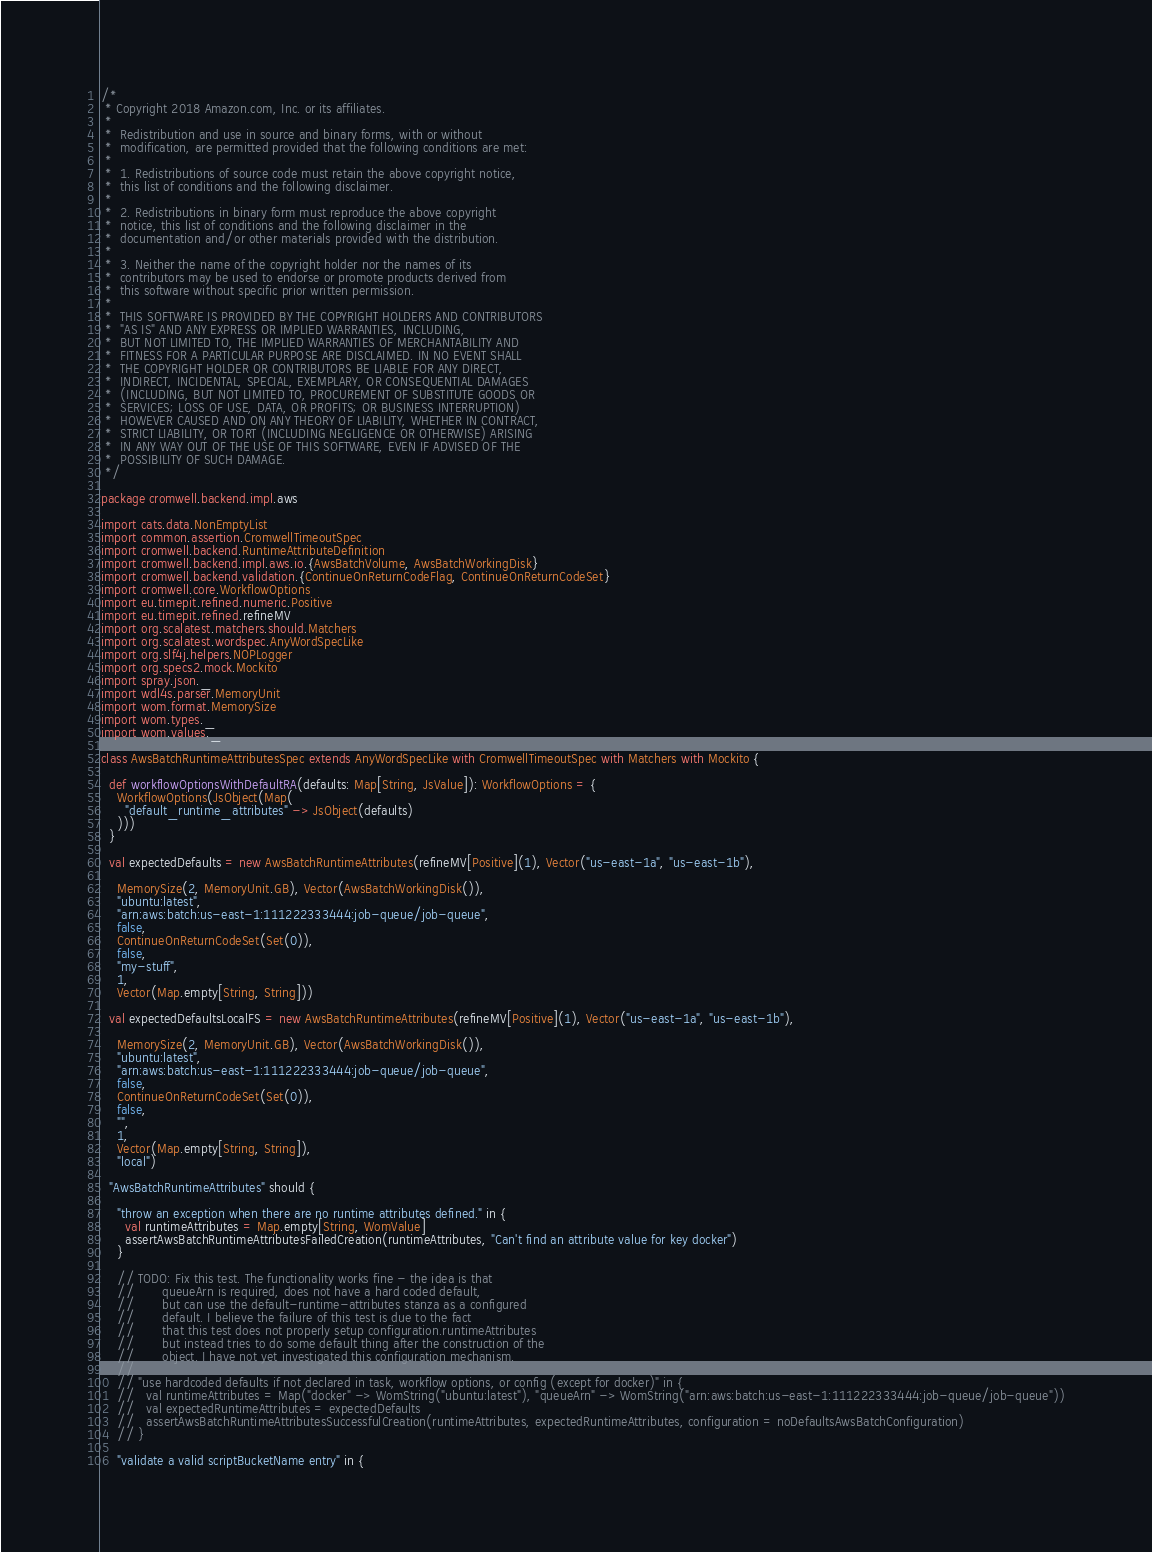<code> <loc_0><loc_0><loc_500><loc_500><_Scala_>/*
 * Copyright 2018 Amazon.com, Inc. or its affiliates.
 *
 *  Redistribution and use in source and binary forms, with or without
 *  modification, are permitted provided that the following conditions are met:
 *
 *  1. Redistributions of source code must retain the above copyright notice,
 *  this list of conditions and the following disclaimer.
 *
 *  2. Redistributions in binary form must reproduce the above copyright
 *  notice, this list of conditions and the following disclaimer in the
 *  documentation and/or other materials provided with the distribution.
 *
 *  3. Neither the name of the copyright holder nor the names of its
 *  contributors may be used to endorse or promote products derived from
 *  this software without specific prior written permission.
 *
 *  THIS SOFTWARE IS PROVIDED BY THE COPYRIGHT HOLDERS AND CONTRIBUTORS
 *  "AS IS" AND ANY EXPRESS OR IMPLIED WARRANTIES, INCLUDING,
 *  BUT NOT LIMITED TO, THE IMPLIED WARRANTIES OF MERCHANTABILITY AND
 *  FITNESS FOR A PARTICULAR PURPOSE ARE DISCLAIMED. IN NO EVENT SHALL
 *  THE COPYRIGHT HOLDER OR CONTRIBUTORS BE LIABLE FOR ANY DIRECT,
 *  INDIRECT, INCIDENTAL, SPECIAL, EXEMPLARY, OR CONSEQUENTIAL DAMAGES
 *  (INCLUDING, BUT NOT LIMITED TO, PROCUREMENT OF SUBSTITUTE GOODS OR
 *  SERVICES; LOSS OF USE, DATA, OR PROFITS; OR BUSINESS INTERRUPTION)
 *  HOWEVER CAUSED AND ON ANY THEORY OF LIABILITY, WHETHER IN CONTRACT,
 *  STRICT LIABILITY, OR TORT (INCLUDING NEGLIGENCE OR OTHERWISE) ARISING
 *  IN ANY WAY OUT OF THE USE OF THIS SOFTWARE, EVEN IF ADVISED OF THE
 *  POSSIBILITY OF SUCH DAMAGE.
 */

package cromwell.backend.impl.aws

import cats.data.NonEmptyList
import common.assertion.CromwellTimeoutSpec
import cromwell.backend.RuntimeAttributeDefinition
import cromwell.backend.impl.aws.io.{AwsBatchVolume, AwsBatchWorkingDisk}
import cromwell.backend.validation.{ContinueOnReturnCodeFlag, ContinueOnReturnCodeSet}
import cromwell.core.WorkflowOptions
import eu.timepit.refined.numeric.Positive
import eu.timepit.refined.refineMV
import org.scalatest.matchers.should.Matchers
import org.scalatest.wordspec.AnyWordSpecLike
import org.slf4j.helpers.NOPLogger
import org.specs2.mock.Mockito
import spray.json._
import wdl4s.parser.MemoryUnit
import wom.format.MemorySize
import wom.types._
import wom.values._

class AwsBatchRuntimeAttributesSpec extends AnyWordSpecLike with CromwellTimeoutSpec with Matchers with Mockito {

  def workflowOptionsWithDefaultRA(defaults: Map[String, JsValue]): WorkflowOptions = {
    WorkflowOptions(JsObject(Map(
      "default_runtime_attributes" -> JsObject(defaults)
    )))
  }

  val expectedDefaults = new AwsBatchRuntimeAttributes(refineMV[Positive](1), Vector("us-east-1a", "us-east-1b"),

    MemorySize(2, MemoryUnit.GB), Vector(AwsBatchWorkingDisk()),
    "ubuntu:latest",
    "arn:aws:batch:us-east-1:111222333444:job-queue/job-queue",
    false,
    ContinueOnReturnCodeSet(Set(0)),
    false,
    "my-stuff",
    1,
    Vector(Map.empty[String, String]))

  val expectedDefaultsLocalFS = new AwsBatchRuntimeAttributes(refineMV[Positive](1), Vector("us-east-1a", "us-east-1b"),

    MemorySize(2, MemoryUnit.GB), Vector(AwsBatchWorkingDisk()),
    "ubuntu:latest",
    "arn:aws:batch:us-east-1:111222333444:job-queue/job-queue",
    false,
    ContinueOnReturnCodeSet(Set(0)),
    false,
    "",
    1,
    Vector(Map.empty[String, String]),
    "local")

  "AwsBatchRuntimeAttributes" should {

    "throw an exception when there are no runtime attributes defined." in {
      val runtimeAttributes = Map.empty[String, WomValue]
      assertAwsBatchRuntimeAttributesFailedCreation(runtimeAttributes, "Can't find an attribute value for key docker")
    }

    // TODO: Fix this test. The functionality works fine - the idea is that
    //       queueArn is required, does not have a hard coded default,
    //       but can use the default-runtime-attributes stanza as a configured
    //       default. I believe the failure of this test is due to the fact
    //       that this test does not properly setup configuration.runtimeAttributes
    //       but instead tries to do some default thing after the construction of the
    //       object. I have not yet investigated this configuration mechanism.
    //
    // "use hardcoded defaults if not declared in task, workflow options, or config (except for docker)" in {
    //   val runtimeAttributes = Map("docker" -> WomString("ubuntu:latest"), "queueArn" -> WomString("arn:aws:batch:us-east-1:111222333444:job-queue/job-queue"))
    //   val expectedRuntimeAttributes = expectedDefaults
    //   assertAwsBatchRuntimeAttributesSuccessfulCreation(runtimeAttributes, expectedRuntimeAttributes, configuration = noDefaultsAwsBatchConfiguration)
    // }

    "validate a valid scriptBucketName entry" in {</code> 